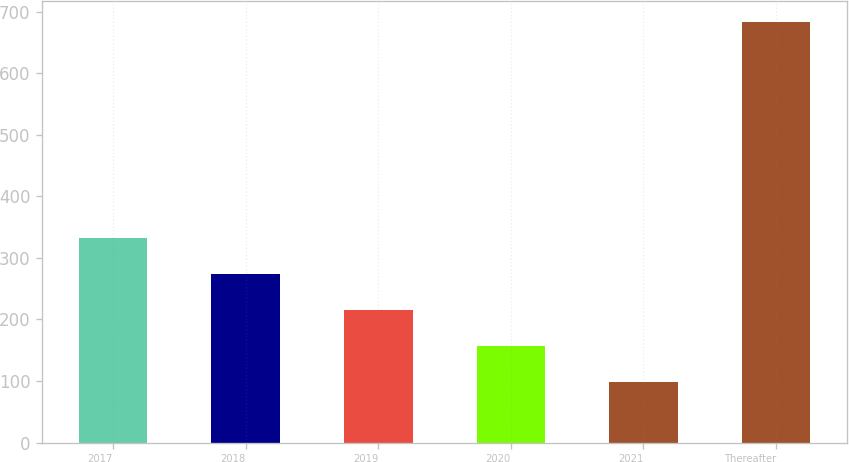<chart> <loc_0><loc_0><loc_500><loc_500><bar_chart><fcel>2017<fcel>2018<fcel>2019<fcel>2020<fcel>2021<fcel>Thereafter<nl><fcel>332.56<fcel>274.22<fcel>215.88<fcel>157.54<fcel>99.2<fcel>682.6<nl></chart> 